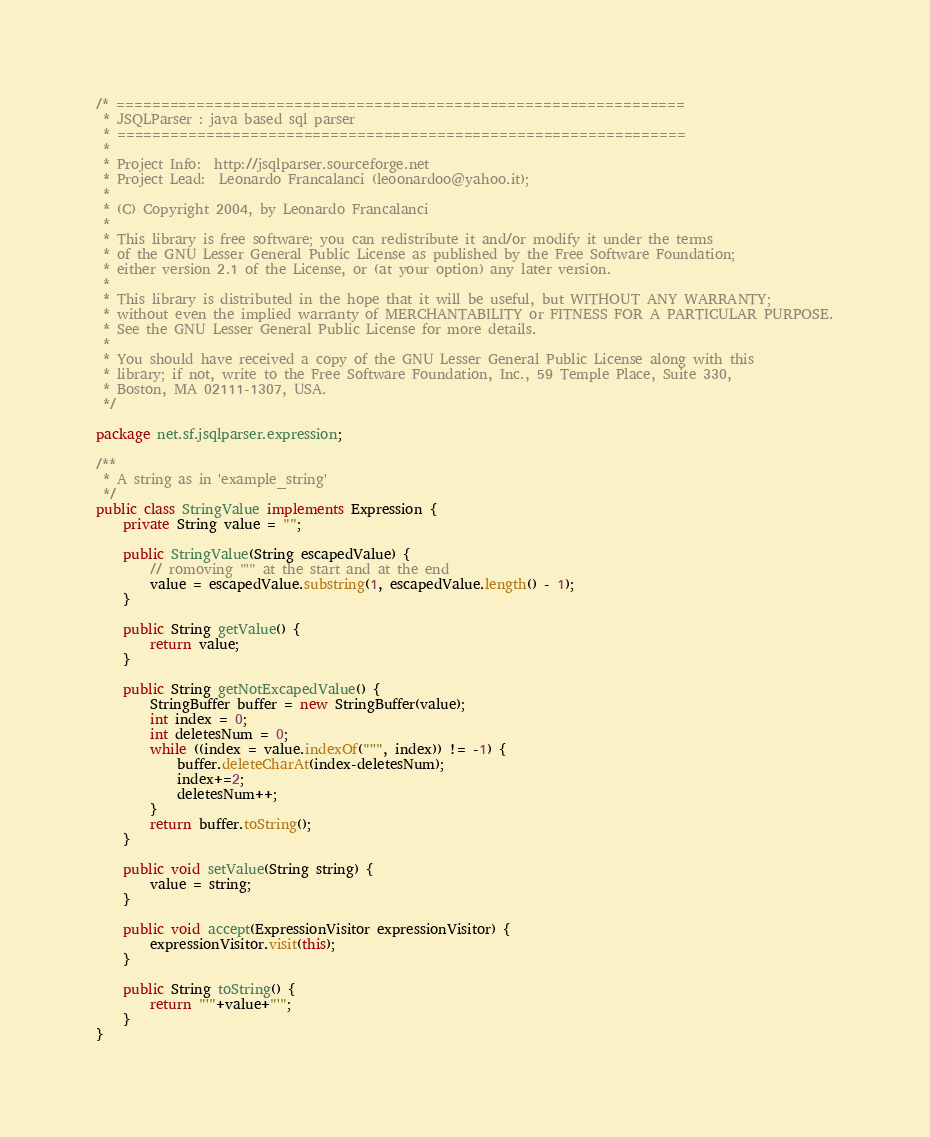<code> <loc_0><loc_0><loc_500><loc_500><_Java_>/* ================================================================
 * JSQLParser : java based sql parser 
 * ================================================================
 *
 * Project Info:  http://jsqlparser.sourceforge.net
 * Project Lead:  Leonardo Francalanci (leoonardoo@yahoo.it);
 *
 * (C) Copyright 2004, by Leonardo Francalanci
 *
 * This library is free software; you can redistribute it and/or modify it under the terms
 * of the GNU Lesser General Public License as published by the Free Software Foundation;
 * either version 2.1 of the License, or (at your option) any later version.
 *
 * This library is distributed in the hope that it will be useful, but WITHOUT ANY WARRANTY;
 * without even the implied warranty of MERCHANTABILITY or FITNESS FOR A PARTICULAR PURPOSE.
 * See the GNU Lesser General Public License for more details.
 *
 * You should have received a copy of the GNU Lesser General Public License along with this
 * library; if not, write to the Free Software Foundation, Inc., 59 Temple Place, Suite 330,
 * Boston, MA 02111-1307, USA.
 */
 
package net.sf.jsqlparser.expression;

/**
 * A string as in 'example_string'
 */
public class StringValue implements Expression {
	private String value = "";
	
	public StringValue(String escapedValue) {
		// romoving "'" at the start and at the end 
		value = escapedValue.substring(1, escapedValue.length() - 1);
	}
	
	public String getValue() {
		return value;
	}

	public String getNotExcapedValue() {
		StringBuffer buffer = new StringBuffer(value);
		int index = 0;
		int deletesNum = 0;
		while ((index = value.indexOf("''", index)) != -1) {
			buffer.deleteCharAt(index-deletesNum);
			index+=2;
			deletesNum++;
		}
		return buffer.toString();
	}

	public void setValue(String string) {
		value = string;
	}
	
	public void accept(ExpressionVisitor expressionVisitor) {
		expressionVisitor.visit(this);
	}

	public String toString() {
		return "'"+value+"'";
	}
}
</code> 